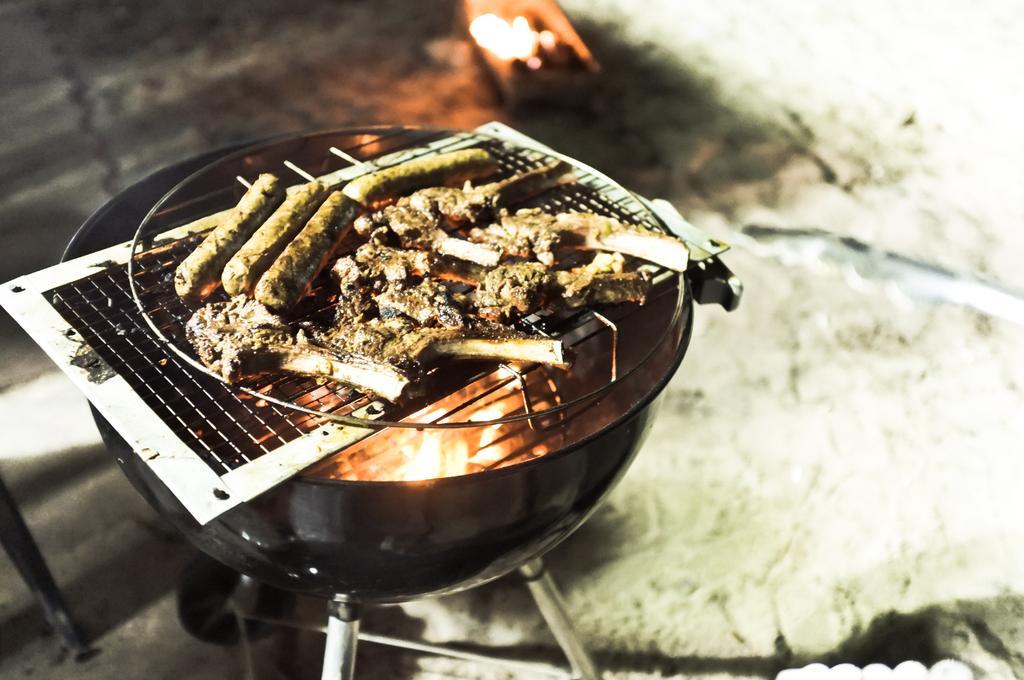Can you describe this image briefly? In this image we can see some food items on a grill and a bowl with fire under the grill and a blurry background. 